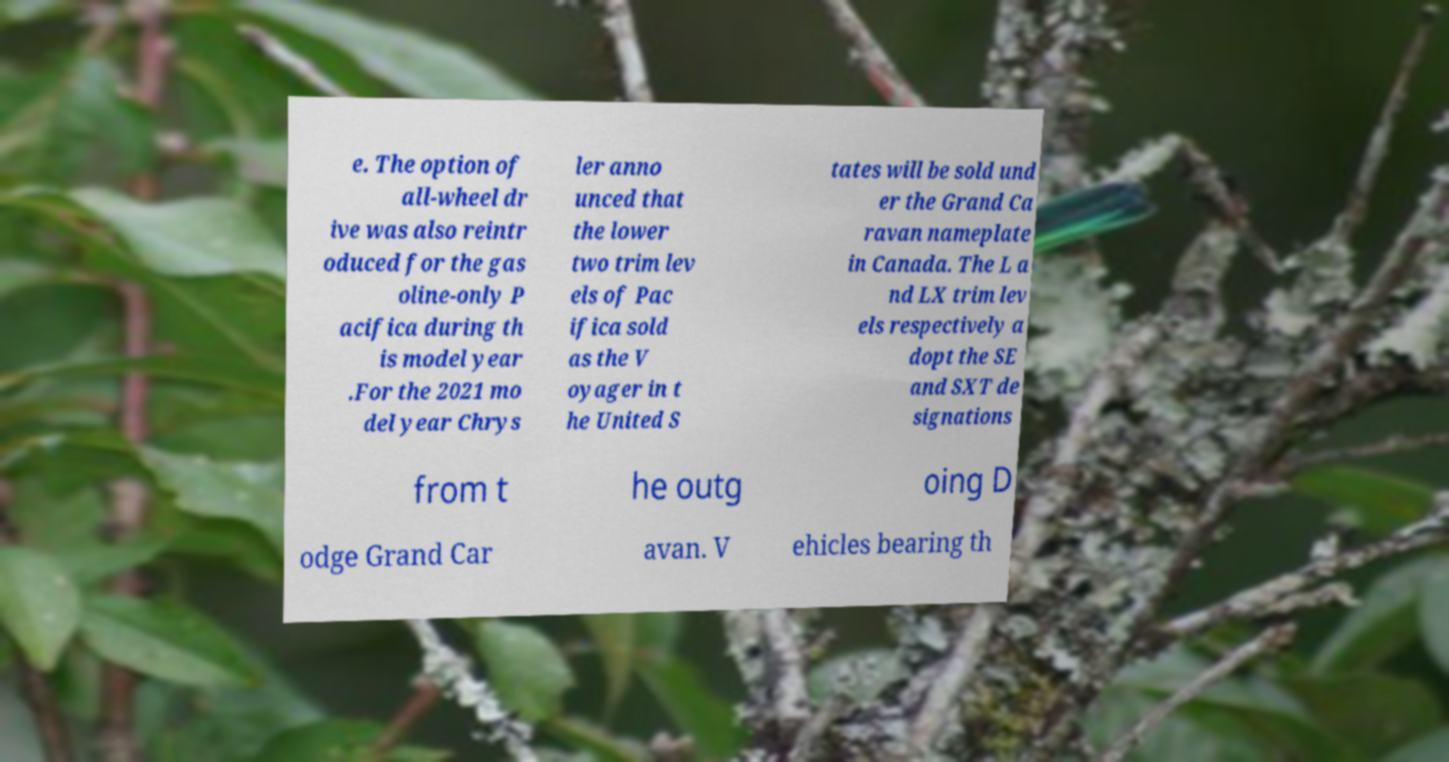Can you read and provide the text displayed in the image?This photo seems to have some interesting text. Can you extract and type it out for me? e. The option of all-wheel dr ive was also reintr oduced for the gas oline-only P acifica during th is model year .For the 2021 mo del year Chrys ler anno unced that the lower two trim lev els of Pac ifica sold as the V oyager in t he United S tates will be sold und er the Grand Ca ravan nameplate in Canada. The L a nd LX trim lev els respectively a dopt the SE and SXT de signations from t he outg oing D odge Grand Car avan. V ehicles bearing th 